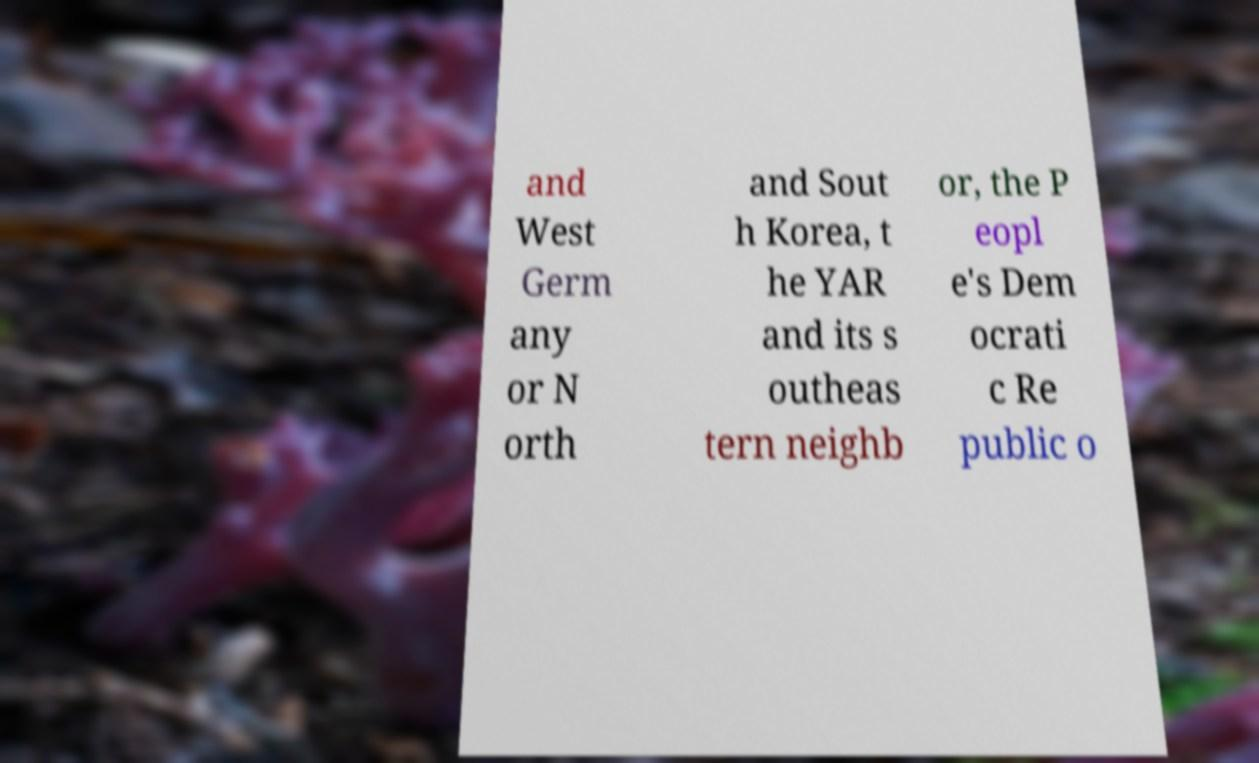For documentation purposes, I need the text within this image transcribed. Could you provide that? and West Germ any or N orth and Sout h Korea, t he YAR and its s outheas tern neighb or, the P eopl e's Dem ocrati c Re public o 